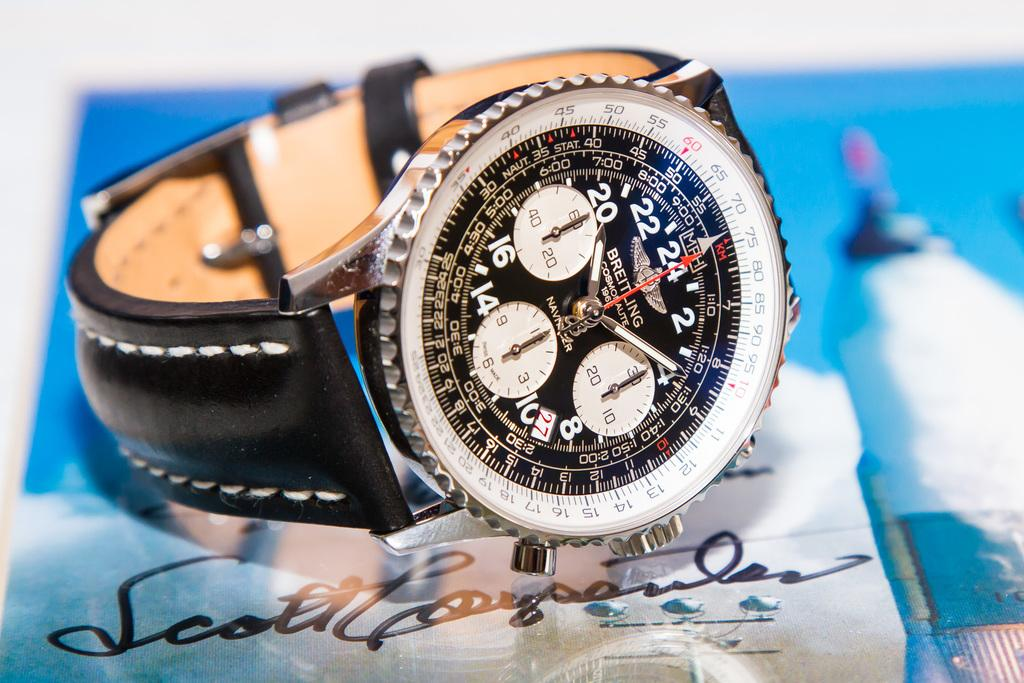<image>
Offer a succinct explanation of the picture presented. A watch lies sideways on top of Scott's autograph. 